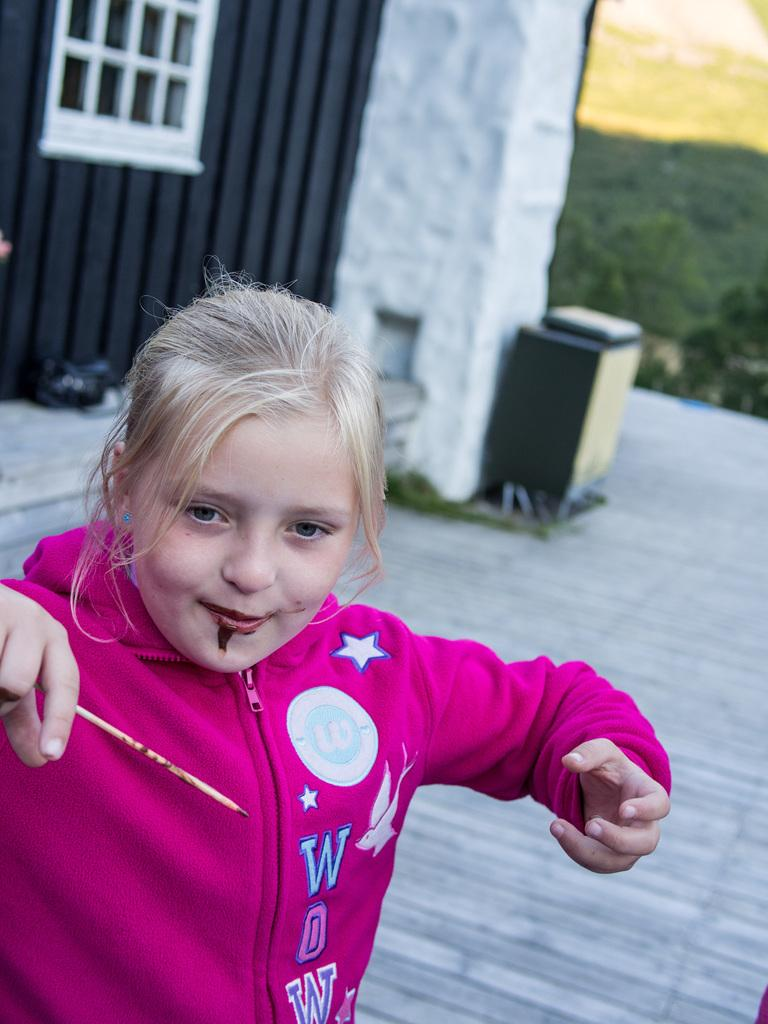<image>
Create a compact narrative representing the image presented. a girl that has WOW written on her pink jacket 